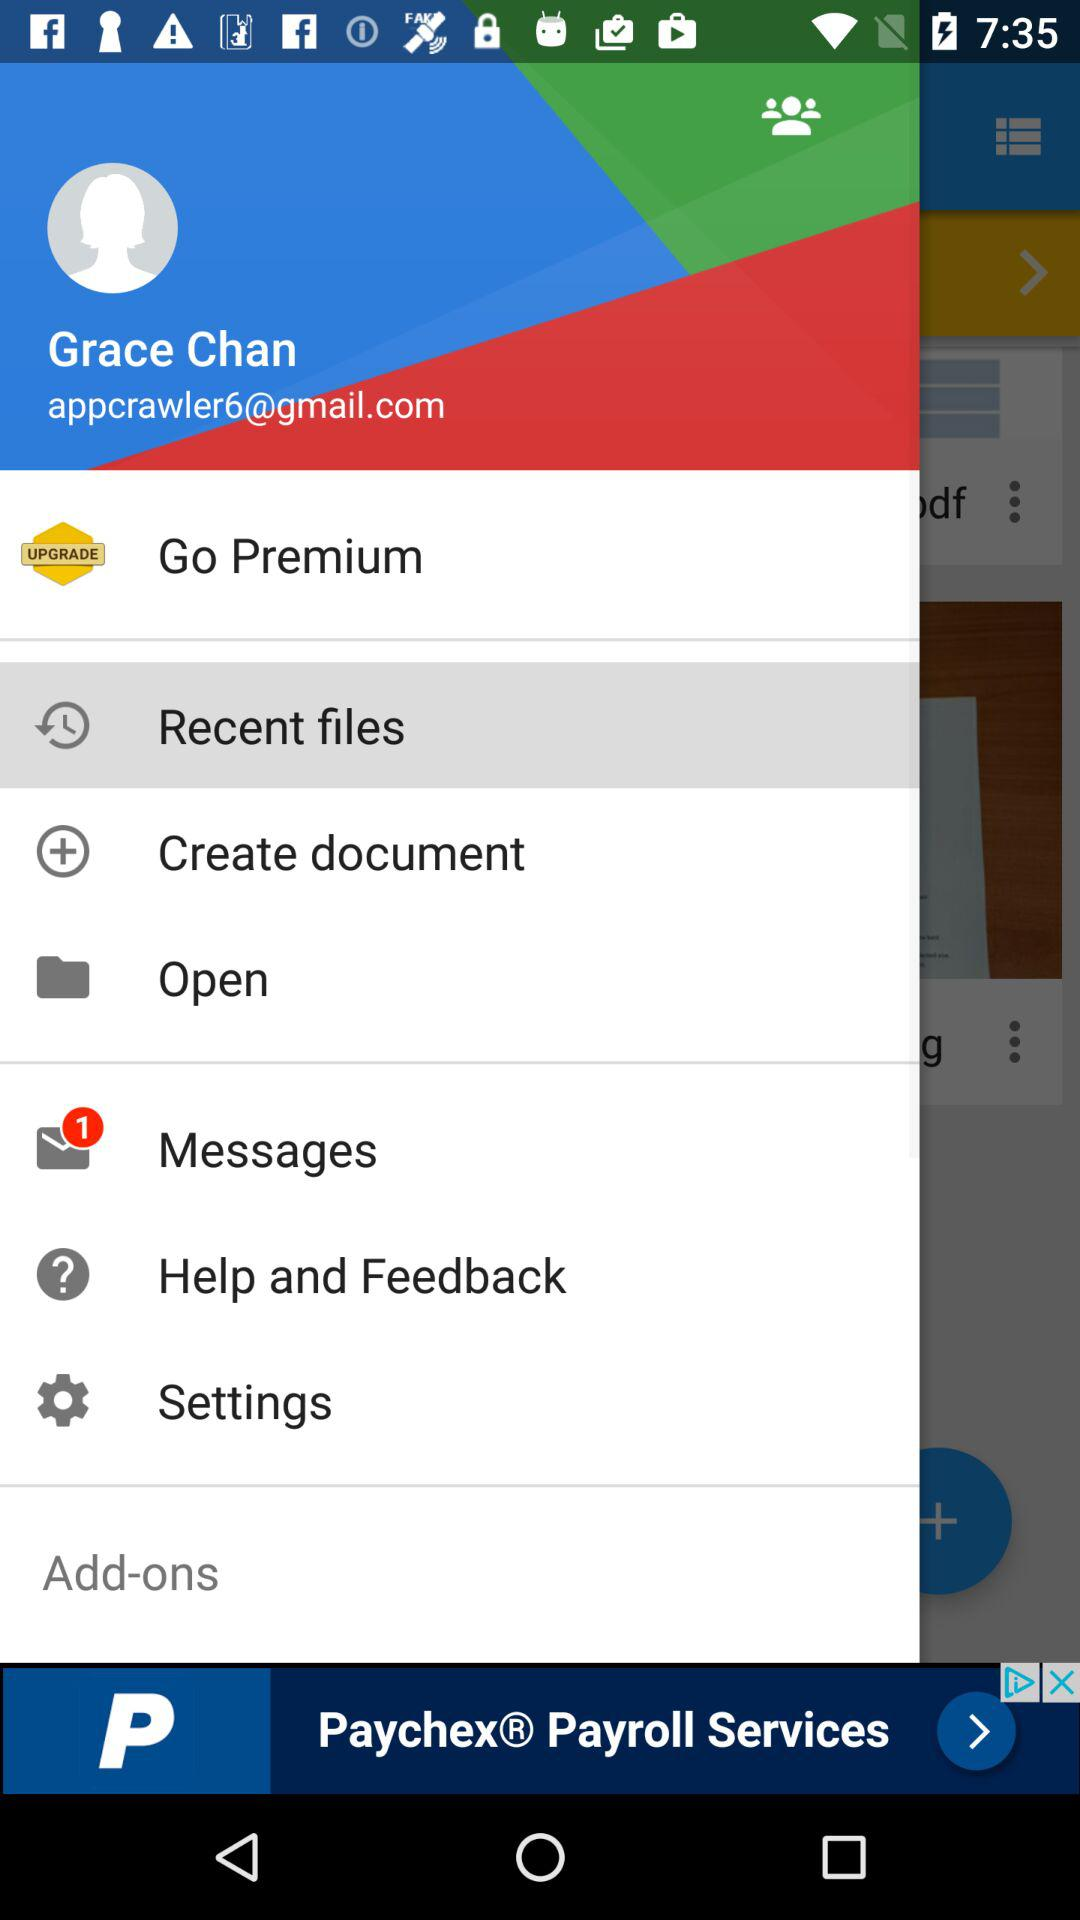What is the name of the user? The name of the user is Grace Chan. 